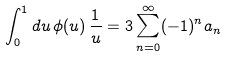Convert formula to latex. <formula><loc_0><loc_0><loc_500><loc_500>\int _ { 0 } ^ { 1 } d u \, \phi ( u ) \, \frac { 1 } { u } = 3 \sum _ { n = 0 } ^ { \infty } ( - 1 ) ^ { n } a _ { n }</formula> 